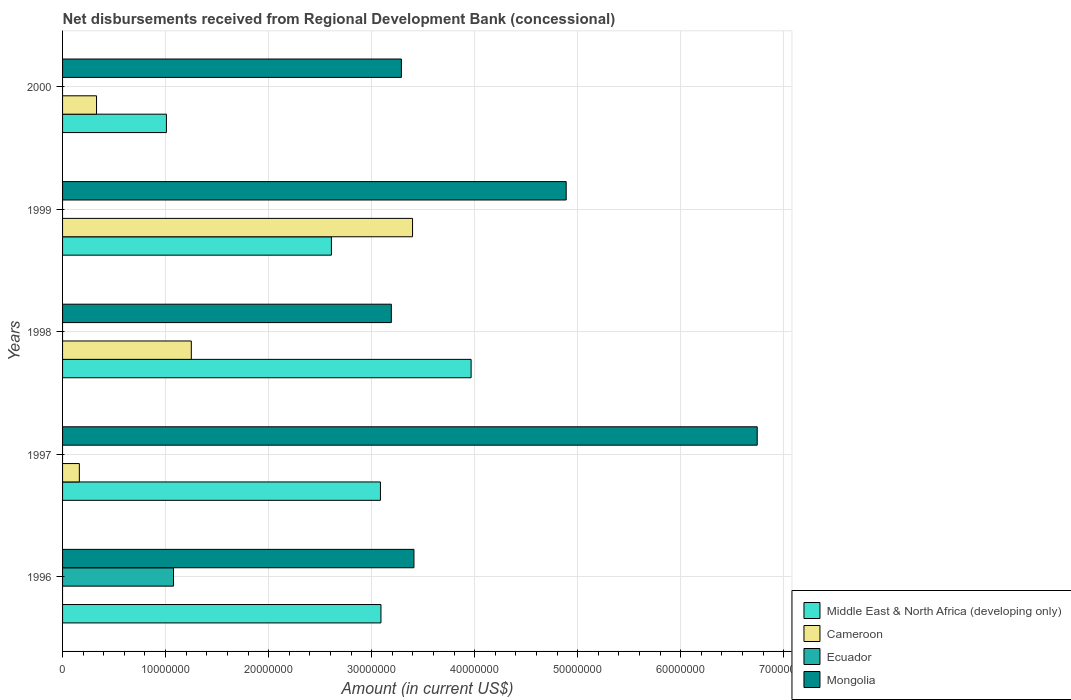How many groups of bars are there?
Your answer should be compact. 5. How many bars are there on the 4th tick from the top?
Make the answer very short. 3. What is the label of the 4th group of bars from the top?
Give a very brief answer. 1997. In how many cases, is the number of bars for a given year not equal to the number of legend labels?
Provide a short and direct response. 5. What is the amount of disbursements received from Regional Development Bank in Mongolia in 1998?
Provide a succinct answer. 3.19e+07. Across all years, what is the maximum amount of disbursements received from Regional Development Bank in Mongolia?
Keep it short and to the point. 6.74e+07. Across all years, what is the minimum amount of disbursements received from Regional Development Bank in Ecuador?
Provide a short and direct response. 0. What is the total amount of disbursements received from Regional Development Bank in Ecuador in the graph?
Ensure brevity in your answer.  1.08e+07. What is the difference between the amount of disbursements received from Regional Development Bank in Cameroon in 1997 and that in 1999?
Make the answer very short. -3.23e+07. What is the difference between the amount of disbursements received from Regional Development Bank in Mongolia in 2000 and the amount of disbursements received from Regional Development Bank in Ecuador in 1998?
Provide a short and direct response. 3.29e+07. What is the average amount of disbursements received from Regional Development Bank in Ecuador per year?
Your response must be concise. 2.15e+06. In the year 2000, what is the difference between the amount of disbursements received from Regional Development Bank in Middle East & North Africa (developing only) and amount of disbursements received from Regional Development Bank in Mongolia?
Keep it short and to the point. -2.28e+07. What is the ratio of the amount of disbursements received from Regional Development Bank in Middle East & North Africa (developing only) in 1996 to that in 2000?
Ensure brevity in your answer.  3.07. Is the amount of disbursements received from Regional Development Bank in Cameroon in 1998 less than that in 1999?
Your answer should be very brief. Yes. What is the difference between the highest and the second highest amount of disbursements received from Regional Development Bank in Mongolia?
Offer a terse response. 1.85e+07. What is the difference between the highest and the lowest amount of disbursements received from Regional Development Bank in Cameroon?
Offer a terse response. 3.40e+07. Is the sum of the amount of disbursements received from Regional Development Bank in Middle East & North Africa (developing only) in 1996 and 1998 greater than the maximum amount of disbursements received from Regional Development Bank in Cameroon across all years?
Provide a succinct answer. Yes. How many bars are there?
Provide a short and direct response. 15. Are all the bars in the graph horizontal?
Give a very brief answer. Yes. Are the values on the major ticks of X-axis written in scientific E-notation?
Your answer should be compact. No. Where does the legend appear in the graph?
Provide a succinct answer. Bottom right. How many legend labels are there?
Ensure brevity in your answer.  4. How are the legend labels stacked?
Your response must be concise. Vertical. What is the title of the graph?
Offer a very short reply. Net disbursements received from Regional Development Bank (concessional). What is the label or title of the X-axis?
Your answer should be very brief. Amount (in current US$). What is the label or title of the Y-axis?
Give a very brief answer. Years. What is the Amount (in current US$) in Middle East & North Africa (developing only) in 1996?
Make the answer very short. 3.09e+07. What is the Amount (in current US$) in Cameroon in 1996?
Provide a succinct answer. 0. What is the Amount (in current US$) of Ecuador in 1996?
Your answer should be compact. 1.08e+07. What is the Amount (in current US$) of Mongolia in 1996?
Keep it short and to the point. 3.41e+07. What is the Amount (in current US$) of Middle East & North Africa (developing only) in 1997?
Keep it short and to the point. 3.09e+07. What is the Amount (in current US$) in Cameroon in 1997?
Your answer should be very brief. 1.63e+06. What is the Amount (in current US$) of Mongolia in 1997?
Keep it short and to the point. 6.74e+07. What is the Amount (in current US$) in Middle East & North Africa (developing only) in 1998?
Provide a short and direct response. 3.97e+07. What is the Amount (in current US$) of Cameroon in 1998?
Provide a short and direct response. 1.25e+07. What is the Amount (in current US$) in Mongolia in 1998?
Give a very brief answer. 3.19e+07. What is the Amount (in current US$) in Middle East & North Africa (developing only) in 1999?
Your answer should be compact. 2.61e+07. What is the Amount (in current US$) of Cameroon in 1999?
Give a very brief answer. 3.40e+07. What is the Amount (in current US$) in Ecuador in 1999?
Your answer should be compact. 0. What is the Amount (in current US$) in Mongolia in 1999?
Make the answer very short. 4.89e+07. What is the Amount (in current US$) of Middle East & North Africa (developing only) in 2000?
Offer a very short reply. 1.01e+07. What is the Amount (in current US$) in Cameroon in 2000?
Your response must be concise. 3.30e+06. What is the Amount (in current US$) in Ecuador in 2000?
Offer a terse response. 0. What is the Amount (in current US$) of Mongolia in 2000?
Provide a succinct answer. 3.29e+07. Across all years, what is the maximum Amount (in current US$) of Middle East & North Africa (developing only)?
Keep it short and to the point. 3.97e+07. Across all years, what is the maximum Amount (in current US$) of Cameroon?
Your response must be concise. 3.40e+07. Across all years, what is the maximum Amount (in current US$) of Ecuador?
Provide a succinct answer. 1.08e+07. Across all years, what is the maximum Amount (in current US$) of Mongolia?
Offer a very short reply. 6.74e+07. Across all years, what is the minimum Amount (in current US$) in Middle East & North Africa (developing only)?
Give a very brief answer. 1.01e+07. Across all years, what is the minimum Amount (in current US$) in Ecuador?
Your answer should be very brief. 0. Across all years, what is the minimum Amount (in current US$) of Mongolia?
Your answer should be very brief. 3.19e+07. What is the total Amount (in current US$) of Middle East & North Africa (developing only) in the graph?
Give a very brief answer. 1.38e+08. What is the total Amount (in current US$) in Cameroon in the graph?
Make the answer very short. 5.14e+07. What is the total Amount (in current US$) in Ecuador in the graph?
Offer a very short reply. 1.08e+07. What is the total Amount (in current US$) in Mongolia in the graph?
Provide a succinct answer. 2.15e+08. What is the difference between the Amount (in current US$) in Mongolia in 1996 and that in 1997?
Provide a short and direct response. -3.33e+07. What is the difference between the Amount (in current US$) of Middle East & North Africa (developing only) in 1996 and that in 1998?
Your response must be concise. -8.75e+06. What is the difference between the Amount (in current US$) in Mongolia in 1996 and that in 1998?
Make the answer very short. 2.19e+06. What is the difference between the Amount (in current US$) of Middle East & North Africa (developing only) in 1996 and that in 1999?
Ensure brevity in your answer.  4.81e+06. What is the difference between the Amount (in current US$) in Mongolia in 1996 and that in 1999?
Your answer should be very brief. -1.48e+07. What is the difference between the Amount (in current US$) in Middle East & North Africa (developing only) in 1996 and that in 2000?
Provide a short and direct response. 2.08e+07. What is the difference between the Amount (in current US$) in Mongolia in 1996 and that in 2000?
Keep it short and to the point. 1.22e+06. What is the difference between the Amount (in current US$) of Middle East & North Africa (developing only) in 1997 and that in 1998?
Give a very brief answer. -8.80e+06. What is the difference between the Amount (in current US$) of Cameroon in 1997 and that in 1998?
Your answer should be compact. -1.09e+07. What is the difference between the Amount (in current US$) in Mongolia in 1997 and that in 1998?
Ensure brevity in your answer.  3.55e+07. What is the difference between the Amount (in current US$) in Middle East & North Africa (developing only) in 1997 and that in 1999?
Make the answer very short. 4.76e+06. What is the difference between the Amount (in current US$) in Cameroon in 1997 and that in 1999?
Offer a terse response. -3.23e+07. What is the difference between the Amount (in current US$) in Mongolia in 1997 and that in 1999?
Offer a very short reply. 1.85e+07. What is the difference between the Amount (in current US$) of Middle East & North Africa (developing only) in 1997 and that in 2000?
Offer a terse response. 2.08e+07. What is the difference between the Amount (in current US$) of Cameroon in 1997 and that in 2000?
Give a very brief answer. -1.67e+06. What is the difference between the Amount (in current US$) in Mongolia in 1997 and that in 2000?
Offer a very short reply. 3.45e+07. What is the difference between the Amount (in current US$) of Middle East & North Africa (developing only) in 1998 and that in 1999?
Provide a short and direct response. 1.36e+07. What is the difference between the Amount (in current US$) in Cameroon in 1998 and that in 1999?
Offer a terse response. -2.15e+07. What is the difference between the Amount (in current US$) of Mongolia in 1998 and that in 1999?
Offer a terse response. -1.70e+07. What is the difference between the Amount (in current US$) in Middle East & North Africa (developing only) in 1998 and that in 2000?
Make the answer very short. 2.96e+07. What is the difference between the Amount (in current US$) of Cameroon in 1998 and that in 2000?
Provide a succinct answer. 9.20e+06. What is the difference between the Amount (in current US$) in Mongolia in 1998 and that in 2000?
Give a very brief answer. -9.75e+05. What is the difference between the Amount (in current US$) in Middle East & North Africa (developing only) in 1999 and that in 2000?
Give a very brief answer. 1.60e+07. What is the difference between the Amount (in current US$) in Cameroon in 1999 and that in 2000?
Give a very brief answer. 3.07e+07. What is the difference between the Amount (in current US$) of Mongolia in 1999 and that in 2000?
Make the answer very short. 1.60e+07. What is the difference between the Amount (in current US$) of Middle East & North Africa (developing only) in 1996 and the Amount (in current US$) of Cameroon in 1997?
Provide a short and direct response. 2.93e+07. What is the difference between the Amount (in current US$) of Middle East & North Africa (developing only) in 1996 and the Amount (in current US$) of Mongolia in 1997?
Keep it short and to the point. -3.65e+07. What is the difference between the Amount (in current US$) in Ecuador in 1996 and the Amount (in current US$) in Mongolia in 1997?
Offer a very short reply. -5.67e+07. What is the difference between the Amount (in current US$) of Middle East & North Africa (developing only) in 1996 and the Amount (in current US$) of Cameroon in 1998?
Give a very brief answer. 1.84e+07. What is the difference between the Amount (in current US$) of Middle East & North Africa (developing only) in 1996 and the Amount (in current US$) of Mongolia in 1998?
Ensure brevity in your answer.  -1.01e+06. What is the difference between the Amount (in current US$) of Ecuador in 1996 and the Amount (in current US$) of Mongolia in 1998?
Make the answer very short. -2.11e+07. What is the difference between the Amount (in current US$) in Middle East & North Africa (developing only) in 1996 and the Amount (in current US$) in Cameroon in 1999?
Provide a succinct answer. -3.07e+06. What is the difference between the Amount (in current US$) in Middle East & North Africa (developing only) in 1996 and the Amount (in current US$) in Mongolia in 1999?
Ensure brevity in your answer.  -1.80e+07. What is the difference between the Amount (in current US$) in Ecuador in 1996 and the Amount (in current US$) in Mongolia in 1999?
Give a very brief answer. -3.81e+07. What is the difference between the Amount (in current US$) in Middle East & North Africa (developing only) in 1996 and the Amount (in current US$) in Cameroon in 2000?
Make the answer very short. 2.76e+07. What is the difference between the Amount (in current US$) in Middle East & North Africa (developing only) in 1996 and the Amount (in current US$) in Mongolia in 2000?
Keep it short and to the point. -1.98e+06. What is the difference between the Amount (in current US$) of Ecuador in 1996 and the Amount (in current US$) of Mongolia in 2000?
Keep it short and to the point. -2.21e+07. What is the difference between the Amount (in current US$) of Middle East & North Africa (developing only) in 1997 and the Amount (in current US$) of Cameroon in 1998?
Offer a very short reply. 1.84e+07. What is the difference between the Amount (in current US$) of Middle East & North Africa (developing only) in 1997 and the Amount (in current US$) of Mongolia in 1998?
Ensure brevity in your answer.  -1.06e+06. What is the difference between the Amount (in current US$) of Cameroon in 1997 and the Amount (in current US$) of Mongolia in 1998?
Ensure brevity in your answer.  -3.03e+07. What is the difference between the Amount (in current US$) in Middle East & North Africa (developing only) in 1997 and the Amount (in current US$) in Cameroon in 1999?
Your response must be concise. -3.12e+06. What is the difference between the Amount (in current US$) in Middle East & North Africa (developing only) in 1997 and the Amount (in current US$) in Mongolia in 1999?
Your answer should be compact. -1.80e+07. What is the difference between the Amount (in current US$) in Cameroon in 1997 and the Amount (in current US$) in Mongolia in 1999?
Your response must be concise. -4.73e+07. What is the difference between the Amount (in current US$) in Middle East & North Africa (developing only) in 1997 and the Amount (in current US$) in Cameroon in 2000?
Give a very brief answer. 2.76e+07. What is the difference between the Amount (in current US$) in Middle East & North Africa (developing only) in 1997 and the Amount (in current US$) in Mongolia in 2000?
Your answer should be compact. -2.03e+06. What is the difference between the Amount (in current US$) in Cameroon in 1997 and the Amount (in current US$) in Mongolia in 2000?
Provide a short and direct response. -3.13e+07. What is the difference between the Amount (in current US$) of Middle East & North Africa (developing only) in 1998 and the Amount (in current US$) of Cameroon in 1999?
Offer a very short reply. 5.68e+06. What is the difference between the Amount (in current US$) in Middle East & North Africa (developing only) in 1998 and the Amount (in current US$) in Mongolia in 1999?
Give a very brief answer. -9.23e+06. What is the difference between the Amount (in current US$) in Cameroon in 1998 and the Amount (in current US$) in Mongolia in 1999?
Provide a short and direct response. -3.64e+07. What is the difference between the Amount (in current US$) of Middle East & North Africa (developing only) in 1998 and the Amount (in current US$) of Cameroon in 2000?
Offer a terse response. 3.64e+07. What is the difference between the Amount (in current US$) in Middle East & North Africa (developing only) in 1998 and the Amount (in current US$) in Mongolia in 2000?
Provide a succinct answer. 6.77e+06. What is the difference between the Amount (in current US$) in Cameroon in 1998 and the Amount (in current US$) in Mongolia in 2000?
Make the answer very short. -2.04e+07. What is the difference between the Amount (in current US$) in Middle East & North Africa (developing only) in 1999 and the Amount (in current US$) in Cameroon in 2000?
Your answer should be very brief. 2.28e+07. What is the difference between the Amount (in current US$) in Middle East & North Africa (developing only) in 1999 and the Amount (in current US$) in Mongolia in 2000?
Give a very brief answer. -6.79e+06. What is the difference between the Amount (in current US$) in Cameroon in 1999 and the Amount (in current US$) in Mongolia in 2000?
Ensure brevity in your answer.  1.08e+06. What is the average Amount (in current US$) of Middle East & North Africa (developing only) per year?
Give a very brief answer. 2.75e+07. What is the average Amount (in current US$) of Cameroon per year?
Your response must be concise. 1.03e+07. What is the average Amount (in current US$) of Ecuador per year?
Give a very brief answer. 2.15e+06. What is the average Amount (in current US$) of Mongolia per year?
Your answer should be very brief. 4.30e+07. In the year 1996, what is the difference between the Amount (in current US$) in Middle East & North Africa (developing only) and Amount (in current US$) in Ecuador?
Give a very brief answer. 2.01e+07. In the year 1996, what is the difference between the Amount (in current US$) in Middle East & North Africa (developing only) and Amount (in current US$) in Mongolia?
Give a very brief answer. -3.20e+06. In the year 1996, what is the difference between the Amount (in current US$) in Ecuador and Amount (in current US$) in Mongolia?
Your answer should be very brief. -2.33e+07. In the year 1997, what is the difference between the Amount (in current US$) in Middle East & North Africa (developing only) and Amount (in current US$) in Cameroon?
Your answer should be very brief. 2.92e+07. In the year 1997, what is the difference between the Amount (in current US$) of Middle East & North Africa (developing only) and Amount (in current US$) of Mongolia?
Ensure brevity in your answer.  -3.66e+07. In the year 1997, what is the difference between the Amount (in current US$) of Cameroon and Amount (in current US$) of Mongolia?
Keep it short and to the point. -6.58e+07. In the year 1998, what is the difference between the Amount (in current US$) of Middle East & North Africa (developing only) and Amount (in current US$) of Cameroon?
Ensure brevity in your answer.  2.72e+07. In the year 1998, what is the difference between the Amount (in current US$) in Middle East & North Africa (developing only) and Amount (in current US$) in Mongolia?
Give a very brief answer. 7.74e+06. In the year 1998, what is the difference between the Amount (in current US$) in Cameroon and Amount (in current US$) in Mongolia?
Provide a succinct answer. -1.94e+07. In the year 1999, what is the difference between the Amount (in current US$) in Middle East & North Africa (developing only) and Amount (in current US$) in Cameroon?
Provide a succinct answer. -7.88e+06. In the year 1999, what is the difference between the Amount (in current US$) of Middle East & North Africa (developing only) and Amount (in current US$) of Mongolia?
Make the answer very short. -2.28e+07. In the year 1999, what is the difference between the Amount (in current US$) in Cameroon and Amount (in current US$) in Mongolia?
Give a very brief answer. -1.49e+07. In the year 2000, what is the difference between the Amount (in current US$) in Middle East & North Africa (developing only) and Amount (in current US$) in Cameroon?
Keep it short and to the point. 6.78e+06. In the year 2000, what is the difference between the Amount (in current US$) in Middle East & North Africa (developing only) and Amount (in current US$) in Mongolia?
Keep it short and to the point. -2.28e+07. In the year 2000, what is the difference between the Amount (in current US$) in Cameroon and Amount (in current US$) in Mongolia?
Your response must be concise. -2.96e+07. What is the ratio of the Amount (in current US$) in Mongolia in 1996 to that in 1997?
Ensure brevity in your answer.  0.51. What is the ratio of the Amount (in current US$) of Middle East & North Africa (developing only) in 1996 to that in 1998?
Ensure brevity in your answer.  0.78. What is the ratio of the Amount (in current US$) of Mongolia in 1996 to that in 1998?
Provide a succinct answer. 1.07. What is the ratio of the Amount (in current US$) in Middle East & North Africa (developing only) in 1996 to that in 1999?
Your answer should be very brief. 1.18. What is the ratio of the Amount (in current US$) in Mongolia in 1996 to that in 1999?
Ensure brevity in your answer.  0.7. What is the ratio of the Amount (in current US$) in Middle East & North Africa (developing only) in 1996 to that in 2000?
Provide a short and direct response. 3.07. What is the ratio of the Amount (in current US$) of Mongolia in 1996 to that in 2000?
Your answer should be compact. 1.04. What is the ratio of the Amount (in current US$) of Middle East & North Africa (developing only) in 1997 to that in 1998?
Give a very brief answer. 0.78. What is the ratio of the Amount (in current US$) of Cameroon in 1997 to that in 1998?
Provide a short and direct response. 0.13. What is the ratio of the Amount (in current US$) in Mongolia in 1997 to that in 1998?
Keep it short and to the point. 2.11. What is the ratio of the Amount (in current US$) in Middle East & North Africa (developing only) in 1997 to that in 1999?
Provide a short and direct response. 1.18. What is the ratio of the Amount (in current US$) in Cameroon in 1997 to that in 1999?
Your answer should be very brief. 0.05. What is the ratio of the Amount (in current US$) in Mongolia in 1997 to that in 1999?
Your answer should be very brief. 1.38. What is the ratio of the Amount (in current US$) in Middle East & North Africa (developing only) in 1997 to that in 2000?
Your answer should be compact. 3.06. What is the ratio of the Amount (in current US$) of Cameroon in 1997 to that in 2000?
Your answer should be compact. 0.49. What is the ratio of the Amount (in current US$) in Mongolia in 1997 to that in 2000?
Offer a terse response. 2.05. What is the ratio of the Amount (in current US$) of Middle East & North Africa (developing only) in 1998 to that in 1999?
Make the answer very short. 1.52. What is the ratio of the Amount (in current US$) in Cameroon in 1998 to that in 1999?
Offer a very short reply. 0.37. What is the ratio of the Amount (in current US$) of Mongolia in 1998 to that in 1999?
Your response must be concise. 0.65. What is the ratio of the Amount (in current US$) in Middle East & North Africa (developing only) in 1998 to that in 2000?
Offer a terse response. 3.93. What is the ratio of the Amount (in current US$) in Cameroon in 1998 to that in 2000?
Give a very brief answer. 3.79. What is the ratio of the Amount (in current US$) of Mongolia in 1998 to that in 2000?
Give a very brief answer. 0.97. What is the ratio of the Amount (in current US$) of Middle East & North Africa (developing only) in 1999 to that in 2000?
Offer a very short reply. 2.59. What is the ratio of the Amount (in current US$) of Cameroon in 1999 to that in 2000?
Make the answer very short. 10.31. What is the ratio of the Amount (in current US$) in Mongolia in 1999 to that in 2000?
Provide a short and direct response. 1.49. What is the difference between the highest and the second highest Amount (in current US$) of Middle East & North Africa (developing only)?
Provide a succinct answer. 8.75e+06. What is the difference between the highest and the second highest Amount (in current US$) of Cameroon?
Provide a short and direct response. 2.15e+07. What is the difference between the highest and the second highest Amount (in current US$) of Mongolia?
Make the answer very short. 1.85e+07. What is the difference between the highest and the lowest Amount (in current US$) in Middle East & North Africa (developing only)?
Offer a terse response. 2.96e+07. What is the difference between the highest and the lowest Amount (in current US$) of Cameroon?
Provide a short and direct response. 3.40e+07. What is the difference between the highest and the lowest Amount (in current US$) of Ecuador?
Keep it short and to the point. 1.08e+07. What is the difference between the highest and the lowest Amount (in current US$) in Mongolia?
Your answer should be compact. 3.55e+07. 